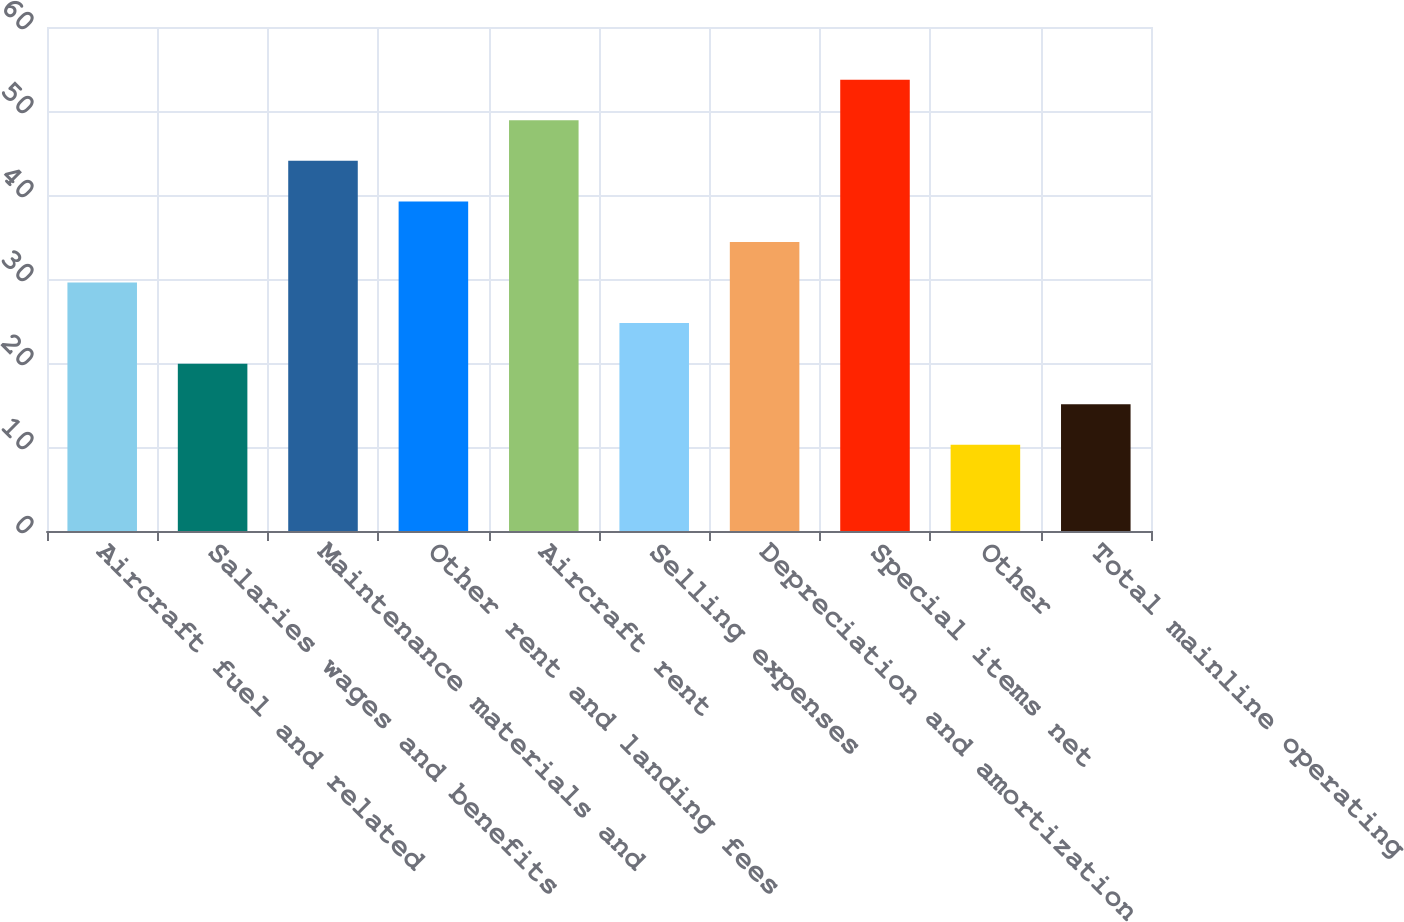Convert chart to OTSL. <chart><loc_0><loc_0><loc_500><loc_500><bar_chart><fcel>Aircraft fuel and related<fcel>Salaries wages and benefits<fcel>Maintenance materials and<fcel>Other rent and landing fees<fcel>Aircraft rent<fcel>Selling expenses<fcel>Depreciation and amortization<fcel>Special items net<fcel>Other<fcel>Total mainline operating<nl><fcel>29.58<fcel>19.92<fcel>44.07<fcel>39.24<fcel>48.9<fcel>24.75<fcel>34.41<fcel>53.73<fcel>10.26<fcel>15.09<nl></chart> 